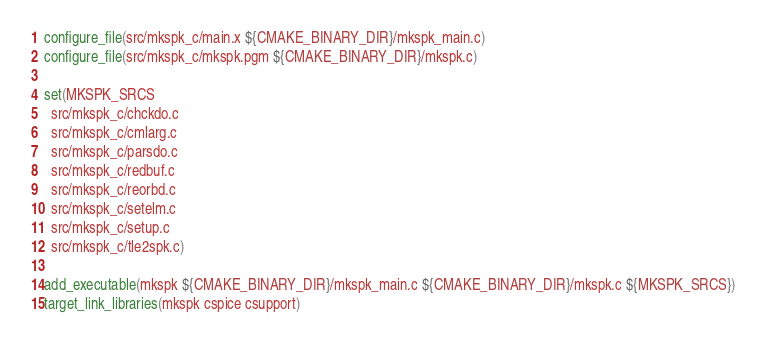<code> <loc_0><loc_0><loc_500><loc_500><_CMake_>configure_file(src/mkspk_c/main.x ${CMAKE_BINARY_DIR}/mkspk_main.c)
configure_file(src/mkspk_c/mkspk.pgm ${CMAKE_BINARY_DIR}/mkspk.c)

set(MKSPK_SRCS
  src/mkspk_c/chckdo.c
  src/mkspk_c/cmlarg.c
  src/mkspk_c/parsdo.c
  src/mkspk_c/redbuf.c
  src/mkspk_c/reorbd.c
  src/mkspk_c/setelm.c
  src/mkspk_c/setup.c
  src/mkspk_c/tle2spk.c)

add_executable(mkspk ${CMAKE_BINARY_DIR}/mkspk_main.c ${CMAKE_BINARY_DIR}/mkspk.c ${MKSPK_SRCS})
target_link_libraries(mkspk cspice csupport)

</code> 